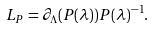Convert formula to latex. <formula><loc_0><loc_0><loc_500><loc_500>L _ { P } = \partial _ { \Lambda } ( P ( \lambda ) ) P ( \lambda ) ^ { - 1 } .</formula> 